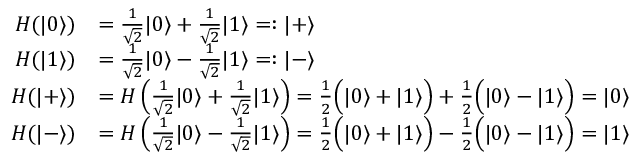Convert formula to latex. <formula><loc_0><loc_0><loc_500><loc_500>{ \begin{array} { r l } { H ( | 0 \rangle ) } & { = { \frac { 1 } { \sqrt { 2 } } } | 0 \rangle + { \frac { 1 } { \sqrt { 2 } } } | 1 \rangle = \colon | + \rangle } \\ { H ( | 1 \rangle ) } & { = { \frac { 1 } { \sqrt { 2 } } } | 0 \rangle - { \frac { 1 } { \sqrt { 2 } } } | 1 \rangle = \colon | - \rangle } \\ { H ( | + \rangle ) } & { = H \left ( { \frac { 1 } { \sqrt { 2 } } } | 0 \rangle + { \frac { 1 } { \sqrt { 2 } } } | 1 \rangle \right ) = { \frac { 1 } { 2 } } { \left ( } | 0 \rangle + | 1 \rangle { \right ) } + { \frac { 1 } { 2 } } { \left ( } | 0 \rangle - | 1 \rangle { \right ) } = | 0 \rangle } \\ { H ( | - \rangle ) } & { = H \left ( { \frac { 1 } { \sqrt { 2 } } } | 0 \rangle - { \frac { 1 } { \sqrt { 2 } } } | 1 \rangle \right ) = { \frac { 1 } { 2 } } { \left ( } | 0 \rangle + | 1 \rangle { \right ) } - { \frac { 1 } { 2 } } { \left ( } | 0 \rangle - | 1 \rangle { \right ) } = | 1 \rangle } \end{array} }</formula> 